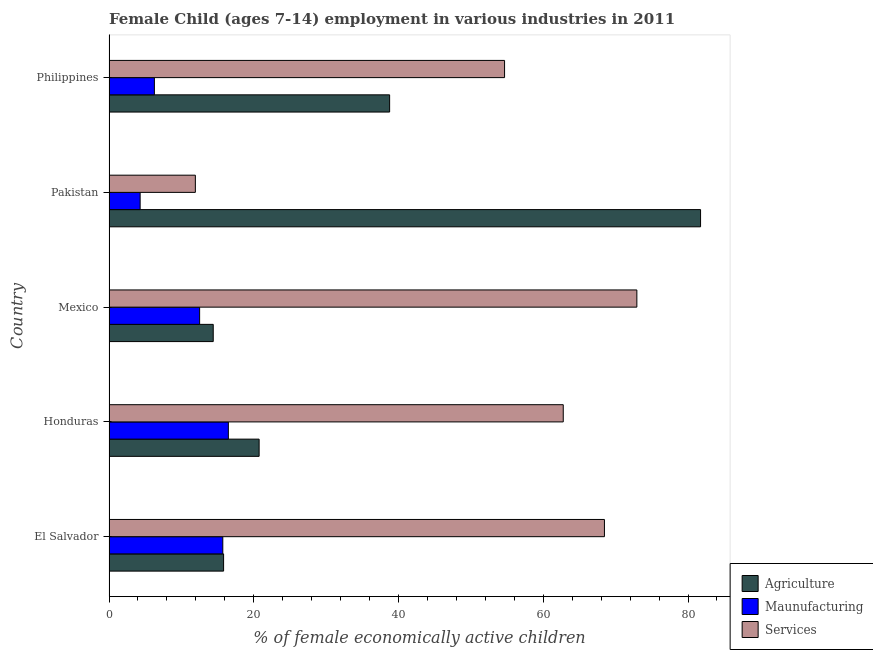How many different coloured bars are there?
Your answer should be very brief. 3. Are the number of bars per tick equal to the number of legend labels?
Offer a terse response. Yes. Are the number of bars on each tick of the Y-axis equal?
Provide a succinct answer. Yes. How many bars are there on the 2nd tick from the bottom?
Offer a terse response. 3. What is the label of the 5th group of bars from the top?
Ensure brevity in your answer.  El Salvador. What is the percentage of economically active children in agriculture in Philippines?
Your answer should be compact. 38.77. Across all countries, what is the maximum percentage of economically active children in services?
Offer a terse response. 72.93. In which country was the percentage of economically active children in manufacturing minimum?
Your answer should be very brief. Pakistan. What is the total percentage of economically active children in agriculture in the graph?
Provide a short and direct response. 171.47. What is the difference between the percentage of economically active children in manufacturing in El Salvador and that in Philippines?
Ensure brevity in your answer.  9.45. What is the difference between the percentage of economically active children in manufacturing in Philippines and the percentage of economically active children in agriculture in Honduras?
Ensure brevity in your answer.  -14.47. What is the average percentage of economically active children in agriculture per country?
Provide a short and direct response. 34.29. What is the difference between the percentage of economically active children in agriculture and percentage of economically active children in manufacturing in Honduras?
Provide a short and direct response. 4.25. In how many countries, is the percentage of economically active children in agriculture greater than 36 %?
Offer a very short reply. 2. What is the ratio of the percentage of economically active children in agriculture in Honduras to that in Mexico?
Your answer should be compact. 1.44. Is the difference between the percentage of economically active children in manufacturing in Pakistan and Philippines greater than the difference between the percentage of economically active children in agriculture in Pakistan and Philippines?
Your answer should be compact. No. What is the difference between the highest and the second highest percentage of economically active children in services?
Give a very brief answer. 4.48. What is the difference between the highest and the lowest percentage of economically active children in agriculture?
Offer a very short reply. 67.33. Is the sum of the percentage of economically active children in agriculture in Mexico and Pakistan greater than the maximum percentage of economically active children in manufacturing across all countries?
Your answer should be compact. Yes. What does the 1st bar from the top in Pakistan represents?
Provide a short and direct response. Services. What does the 3rd bar from the bottom in Honduras represents?
Keep it short and to the point. Services. Is it the case that in every country, the sum of the percentage of economically active children in agriculture and percentage of economically active children in manufacturing is greater than the percentage of economically active children in services?
Offer a terse response. No. How many countries are there in the graph?
Offer a terse response. 5. What is the difference between two consecutive major ticks on the X-axis?
Provide a short and direct response. 20. Are the values on the major ticks of X-axis written in scientific E-notation?
Offer a very short reply. No. Does the graph contain any zero values?
Make the answer very short. No. Does the graph contain grids?
Offer a terse response. No. How are the legend labels stacked?
Ensure brevity in your answer.  Vertical. What is the title of the graph?
Provide a succinct answer. Female Child (ages 7-14) employment in various industries in 2011. Does "Ages 60+" appear as one of the legend labels in the graph?
Offer a very short reply. No. What is the label or title of the X-axis?
Provide a succinct answer. % of female economically active children. What is the label or title of the Y-axis?
Provide a short and direct response. Country. What is the % of female economically active children in Agriculture in El Salvador?
Keep it short and to the point. 15.83. What is the % of female economically active children in Maunufacturing in El Salvador?
Offer a terse response. 15.72. What is the % of female economically active children in Services in El Salvador?
Make the answer very short. 68.45. What is the % of female economically active children of Agriculture in Honduras?
Your response must be concise. 20.74. What is the % of female economically active children of Maunufacturing in Honduras?
Offer a terse response. 16.49. What is the % of female economically active children in Services in Honduras?
Offer a terse response. 62.76. What is the % of female economically active children in Agriculture in Mexico?
Give a very brief answer. 14.4. What is the % of female economically active children in Maunufacturing in Mexico?
Your answer should be compact. 12.52. What is the % of female economically active children in Services in Mexico?
Ensure brevity in your answer.  72.93. What is the % of female economically active children of Agriculture in Pakistan?
Offer a very short reply. 81.73. What is the % of female economically active children in Services in Pakistan?
Your answer should be compact. 11.93. What is the % of female economically active children in Agriculture in Philippines?
Give a very brief answer. 38.77. What is the % of female economically active children of Maunufacturing in Philippines?
Your answer should be compact. 6.27. What is the % of female economically active children of Services in Philippines?
Keep it short and to the point. 54.65. Across all countries, what is the maximum % of female economically active children in Agriculture?
Your answer should be very brief. 81.73. Across all countries, what is the maximum % of female economically active children of Maunufacturing?
Make the answer very short. 16.49. Across all countries, what is the maximum % of female economically active children in Services?
Provide a succinct answer. 72.93. Across all countries, what is the minimum % of female economically active children of Services?
Offer a terse response. 11.93. What is the total % of female economically active children of Agriculture in the graph?
Your answer should be very brief. 171.47. What is the total % of female economically active children of Maunufacturing in the graph?
Give a very brief answer. 55.3. What is the total % of female economically active children in Services in the graph?
Offer a terse response. 270.72. What is the difference between the % of female economically active children in Agriculture in El Salvador and that in Honduras?
Your response must be concise. -4.91. What is the difference between the % of female economically active children in Maunufacturing in El Salvador and that in Honduras?
Offer a terse response. -0.77. What is the difference between the % of female economically active children of Services in El Salvador and that in Honduras?
Offer a very short reply. 5.69. What is the difference between the % of female economically active children in Agriculture in El Salvador and that in Mexico?
Ensure brevity in your answer.  1.43. What is the difference between the % of female economically active children of Services in El Salvador and that in Mexico?
Offer a very short reply. -4.48. What is the difference between the % of female economically active children of Agriculture in El Salvador and that in Pakistan?
Your answer should be compact. -65.9. What is the difference between the % of female economically active children in Maunufacturing in El Salvador and that in Pakistan?
Your answer should be very brief. 11.42. What is the difference between the % of female economically active children in Services in El Salvador and that in Pakistan?
Your answer should be compact. 56.52. What is the difference between the % of female economically active children in Agriculture in El Salvador and that in Philippines?
Provide a short and direct response. -22.94. What is the difference between the % of female economically active children of Maunufacturing in El Salvador and that in Philippines?
Make the answer very short. 9.45. What is the difference between the % of female economically active children in Services in El Salvador and that in Philippines?
Provide a succinct answer. 13.8. What is the difference between the % of female economically active children in Agriculture in Honduras and that in Mexico?
Provide a short and direct response. 6.34. What is the difference between the % of female economically active children in Maunufacturing in Honduras and that in Mexico?
Ensure brevity in your answer.  3.97. What is the difference between the % of female economically active children of Services in Honduras and that in Mexico?
Your answer should be very brief. -10.17. What is the difference between the % of female economically active children in Agriculture in Honduras and that in Pakistan?
Offer a terse response. -60.99. What is the difference between the % of female economically active children in Maunufacturing in Honduras and that in Pakistan?
Offer a very short reply. 12.19. What is the difference between the % of female economically active children in Services in Honduras and that in Pakistan?
Offer a very short reply. 50.83. What is the difference between the % of female economically active children in Agriculture in Honduras and that in Philippines?
Your answer should be compact. -18.03. What is the difference between the % of female economically active children in Maunufacturing in Honduras and that in Philippines?
Your answer should be very brief. 10.22. What is the difference between the % of female economically active children of Services in Honduras and that in Philippines?
Make the answer very short. 8.11. What is the difference between the % of female economically active children in Agriculture in Mexico and that in Pakistan?
Make the answer very short. -67.33. What is the difference between the % of female economically active children in Maunufacturing in Mexico and that in Pakistan?
Your response must be concise. 8.22. What is the difference between the % of female economically active children in Services in Mexico and that in Pakistan?
Your answer should be compact. 61. What is the difference between the % of female economically active children of Agriculture in Mexico and that in Philippines?
Give a very brief answer. -24.37. What is the difference between the % of female economically active children of Maunufacturing in Mexico and that in Philippines?
Give a very brief answer. 6.25. What is the difference between the % of female economically active children of Services in Mexico and that in Philippines?
Provide a succinct answer. 18.28. What is the difference between the % of female economically active children in Agriculture in Pakistan and that in Philippines?
Ensure brevity in your answer.  42.96. What is the difference between the % of female economically active children in Maunufacturing in Pakistan and that in Philippines?
Offer a very short reply. -1.97. What is the difference between the % of female economically active children of Services in Pakistan and that in Philippines?
Offer a terse response. -42.72. What is the difference between the % of female economically active children of Agriculture in El Salvador and the % of female economically active children of Maunufacturing in Honduras?
Offer a very short reply. -0.66. What is the difference between the % of female economically active children in Agriculture in El Salvador and the % of female economically active children in Services in Honduras?
Offer a very short reply. -46.93. What is the difference between the % of female economically active children of Maunufacturing in El Salvador and the % of female economically active children of Services in Honduras?
Provide a short and direct response. -47.04. What is the difference between the % of female economically active children in Agriculture in El Salvador and the % of female economically active children in Maunufacturing in Mexico?
Your answer should be compact. 3.31. What is the difference between the % of female economically active children of Agriculture in El Salvador and the % of female economically active children of Services in Mexico?
Provide a succinct answer. -57.1. What is the difference between the % of female economically active children in Maunufacturing in El Salvador and the % of female economically active children in Services in Mexico?
Offer a very short reply. -57.21. What is the difference between the % of female economically active children in Agriculture in El Salvador and the % of female economically active children in Maunufacturing in Pakistan?
Make the answer very short. 11.53. What is the difference between the % of female economically active children in Agriculture in El Salvador and the % of female economically active children in Services in Pakistan?
Provide a succinct answer. 3.9. What is the difference between the % of female economically active children of Maunufacturing in El Salvador and the % of female economically active children of Services in Pakistan?
Make the answer very short. 3.79. What is the difference between the % of female economically active children in Agriculture in El Salvador and the % of female economically active children in Maunufacturing in Philippines?
Provide a succinct answer. 9.56. What is the difference between the % of female economically active children of Agriculture in El Salvador and the % of female economically active children of Services in Philippines?
Give a very brief answer. -38.82. What is the difference between the % of female economically active children in Maunufacturing in El Salvador and the % of female economically active children in Services in Philippines?
Give a very brief answer. -38.93. What is the difference between the % of female economically active children of Agriculture in Honduras and the % of female economically active children of Maunufacturing in Mexico?
Give a very brief answer. 8.22. What is the difference between the % of female economically active children in Agriculture in Honduras and the % of female economically active children in Services in Mexico?
Your answer should be very brief. -52.19. What is the difference between the % of female economically active children of Maunufacturing in Honduras and the % of female economically active children of Services in Mexico?
Your answer should be compact. -56.44. What is the difference between the % of female economically active children in Agriculture in Honduras and the % of female economically active children in Maunufacturing in Pakistan?
Keep it short and to the point. 16.44. What is the difference between the % of female economically active children in Agriculture in Honduras and the % of female economically active children in Services in Pakistan?
Keep it short and to the point. 8.81. What is the difference between the % of female economically active children in Maunufacturing in Honduras and the % of female economically active children in Services in Pakistan?
Your response must be concise. 4.56. What is the difference between the % of female economically active children in Agriculture in Honduras and the % of female economically active children in Maunufacturing in Philippines?
Give a very brief answer. 14.47. What is the difference between the % of female economically active children of Agriculture in Honduras and the % of female economically active children of Services in Philippines?
Make the answer very short. -33.91. What is the difference between the % of female economically active children in Maunufacturing in Honduras and the % of female economically active children in Services in Philippines?
Your answer should be very brief. -38.16. What is the difference between the % of female economically active children in Agriculture in Mexico and the % of female economically active children in Maunufacturing in Pakistan?
Offer a very short reply. 10.1. What is the difference between the % of female economically active children of Agriculture in Mexico and the % of female economically active children of Services in Pakistan?
Make the answer very short. 2.47. What is the difference between the % of female economically active children in Maunufacturing in Mexico and the % of female economically active children in Services in Pakistan?
Keep it short and to the point. 0.59. What is the difference between the % of female economically active children of Agriculture in Mexico and the % of female economically active children of Maunufacturing in Philippines?
Keep it short and to the point. 8.13. What is the difference between the % of female economically active children of Agriculture in Mexico and the % of female economically active children of Services in Philippines?
Offer a terse response. -40.25. What is the difference between the % of female economically active children of Maunufacturing in Mexico and the % of female economically active children of Services in Philippines?
Offer a very short reply. -42.13. What is the difference between the % of female economically active children of Agriculture in Pakistan and the % of female economically active children of Maunufacturing in Philippines?
Ensure brevity in your answer.  75.46. What is the difference between the % of female economically active children in Agriculture in Pakistan and the % of female economically active children in Services in Philippines?
Keep it short and to the point. 27.08. What is the difference between the % of female economically active children in Maunufacturing in Pakistan and the % of female economically active children in Services in Philippines?
Your answer should be compact. -50.35. What is the average % of female economically active children in Agriculture per country?
Make the answer very short. 34.29. What is the average % of female economically active children of Maunufacturing per country?
Provide a short and direct response. 11.06. What is the average % of female economically active children in Services per country?
Ensure brevity in your answer.  54.14. What is the difference between the % of female economically active children of Agriculture and % of female economically active children of Maunufacturing in El Salvador?
Your answer should be compact. 0.11. What is the difference between the % of female economically active children in Agriculture and % of female economically active children in Services in El Salvador?
Offer a very short reply. -52.62. What is the difference between the % of female economically active children in Maunufacturing and % of female economically active children in Services in El Salvador?
Your answer should be very brief. -52.73. What is the difference between the % of female economically active children in Agriculture and % of female economically active children in Maunufacturing in Honduras?
Keep it short and to the point. 4.25. What is the difference between the % of female economically active children of Agriculture and % of female economically active children of Services in Honduras?
Your answer should be compact. -42.02. What is the difference between the % of female economically active children in Maunufacturing and % of female economically active children in Services in Honduras?
Your answer should be very brief. -46.27. What is the difference between the % of female economically active children in Agriculture and % of female economically active children in Maunufacturing in Mexico?
Ensure brevity in your answer.  1.88. What is the difference between the % of female economically active children in Agriculture and % of female economically active children in Services in Mexico?
Provide a succinct answer. -58.53. What is the difference between the % of female economically active children of Maunufacturing and % of female economically active children of Services in Mexico?
Provide a succinct answer. -60.41. What is the difference between the % of female economically active children of Agriculture and % of female economically active children of Maunufacturing in Pakistan?
Your answer should be very brief. 77.43. What is the difference between the % of female economically active children in Agriculture and % of female economically active children in Services in Pakistan?
Keep it short and to the point. 69.8. What is the difference between the % of female economically active children of Maunufacturing and % of female economically active children of Services in Pakistan?
Give a very brief answer. -7.63. What is the difference between the % of female economically active children in Agriculture and % of female economically active children in Maunufacturing in Philippines?
Provide a succinct answer. 32.5. What is the difference between the % of female economically active children in Agriculture and % of female economically active children in Services in Philippines?
Offer a very short reply. -15.88. What is the difference between the % of female economically active children of Maunufacturing and % of female economically active children of Services in Philippines?
Provide a succinct answer. -48.38. What is the ratio of the % of female economically active children of Agriculture in El Salvador to that in Honduras?
Give a very brief answer. 0.76. What is the ratio of the % of female economically active children of Maunufacturing in El Salvador to that in Honduras?
Ensure brevity in your answer.  0.95. What is the ratio of the % of female economically active children of Services in El Salvador to that in Honduras?
Your answer should be very brief. 1.09. What is the ratio of the % of female economically active children in Agriculture in El Salvador to that in Mexico?
Your response must be concise. 1.1. What is the ratio of the % of female economically active children in Maunufacturing in El Salvador to that in Mexico?
Provide a short and direct response. 1.26. What is the ratio of the % of female economically active children in Services in El Salvador to that in Mexico?
Provide a succinct answer. 0.94. What is the ratio of the % of female economically active children in Agriculture in El Salvador to that in Pakistan?
Offer a very short reply. 0.19. What is the ratio of the % of female economically active children in Maunufacturing in El Salvador to that in Pakistan?
Your answer should be very brief. 3.66. What is the ratio of the % of female economically active children of Services in El Salvador to that in Pakistan?
Give a very brief answer. 5.74. What is the ratio of the % of female economically active children of Agriculture in El Salvador to that in Philippines?
Ensure brevity in your answer.  0.41. What is the ratio of the % of female economically active children in Maunufacturing in El Salvador to that in Philippines?
Make the answer very short. 2.51. What is the ratio of the % of female economically active children in Services in El Salvador to that in Philippines?
Provide a short and direct response. 1.25. What is the ratio of the % of female economically active children in Agriculture in Honduras to that in Mexico?
Give a very brief answer. 1.44. What is the ratio of the % of female economically active children of Maunufacturing in Honduras to that in Mexico?
Provide a succinct answer. 1.32. What is the ratio of the % of female economically active children in Services in Honduras to that in Mexico?
Make the answer very short. 0.86. What is the ratio of the % of female economically active children in Agriculture in Honduras to that in Pakistan?
Your response must be concise. 0.25. What is the ratio of the % of female economically active children of Maunufacturing in Honduras to that in Pakistan?
Make the answer very short. 3.83. What is the ratio of the % of female economically active children in Services in Honduras to that in Pakistan?
Provide a succinct answer. 5.26. What is the ratio of the % of female economically active children in Agriculture in Honduras to that in Philippines?
Give a very brief answer. 0.53. What is the ratio of the % of female economically active children of Maunufacturing in Honduras to that in Philippines?
Your response must be concise. 2.63. What is the ratio of the % of female economically active children of Services in Honduras to that in Philippines?
Keep it short and to the point. 1.15. What is the ratio of the % of female economically active children of Agriculture in Mexico to that in Pakistan?
Offer a terse response. 0.18. What is the ratio of the % of female economically active children of Maunufacturing in Mexico to that in Pakistan?
Provide a short and direct response. 2.91. What is the ratio of the % of female economically active children in Services in Mexico to that in Pakistan?
Your response must be concise. 6.11. What is the ratio of the % of female economically active children in Agriculture in Mexico to that in Philippines?
Give a very brief answer. 0.37. What is the ratio of the % of female economically active children in Maunufacturing in Mexico to that in Philippines?
Ensure brevity in your answer.  2. What is the ratio of the % of female economically active children in Services in Mexico to that in Philippines?
Provide a succinct answer. 1.33. What is the ratio of the % of female economically active children of Agriculture in Pakistan to that in Philippines?
Offer a terse response. 2.11. What is the ratio of the % of female economically active children in Maunufacturing in Pakistan to that in Philippines?
Offer a very short reply. 0.69. What is the ratio of the % of female economically active children of Services in Pakistan to that in Philippines?
Provide a succinct answer. 0.22. What is the difference between the highest and the second highest % of female economically active children of Agriculture?
Offer a terse response. 42.96. What is the difference between the highest and the second highest % of female economically active children of Maunufacturing?
Give a very brief answer. 0.77. What is the difference between the highest and the second highest % of female economically active children of Services?
Your response must be concise. 4.48. What is the difference between the highest and the lowest % of female economically active children in Agriculture?
Provide a short and direct response. 67.33. What is the difference between the highest and the lowest % of female economically active children of Maunufacturing?
Your answer should be very brief. 12.19. 